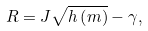Convert formula to latex. <formula><loc_0><loc_0><loc_500><loc_500>R = J \sqrt { h \left ( m \right ) } - \gamma ,</formula> 